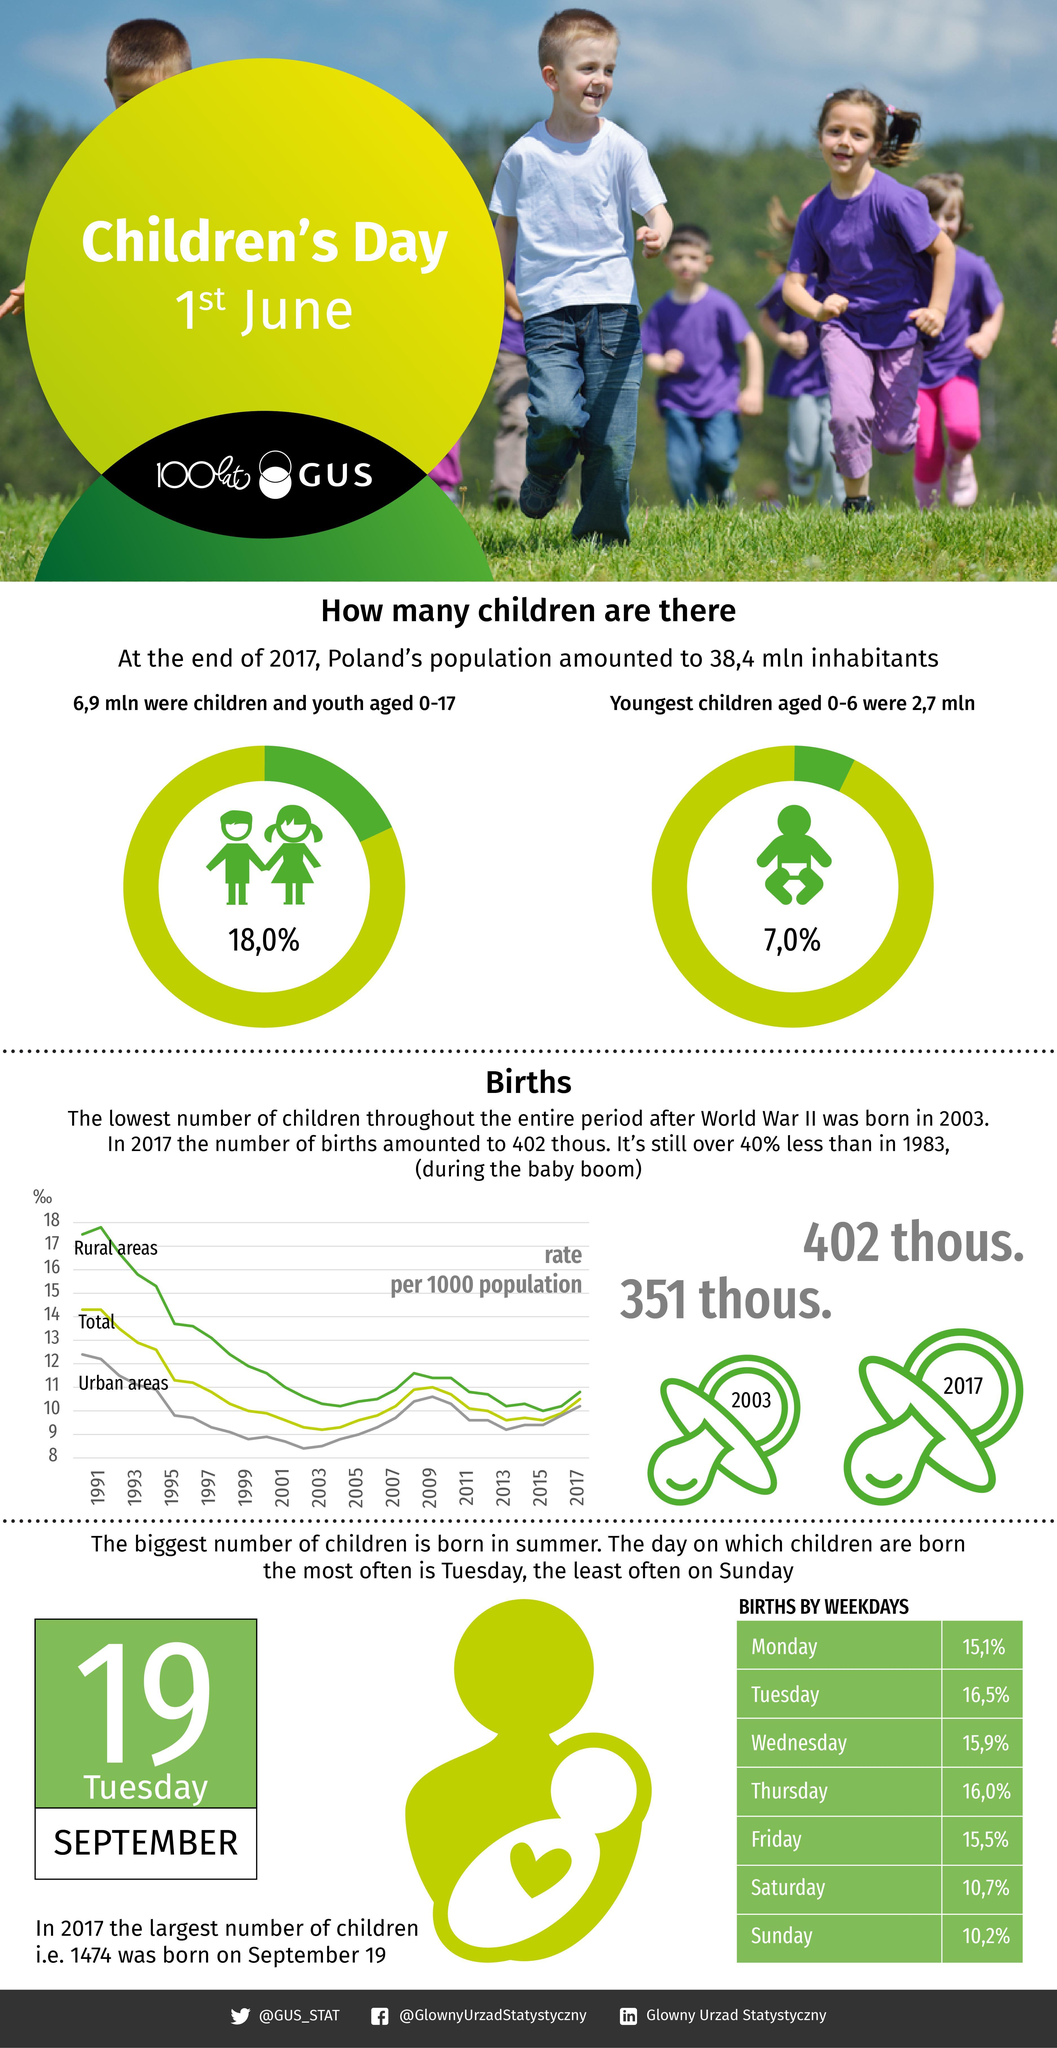Which Facebook account is mentioned?
Answer the question with a short phrase. @GlownyUrzadStatystyczny What is the linked in profile mentioned? Glowny Urzad Statystyczny On which two days of week were births least? Saturday, Sunday Which Twitter handle is mentioned? @GUS_STAT Which year had highest birth rate per 1000 population in urban areas? 1991 What was the number of births in 2017? 402 thous. 